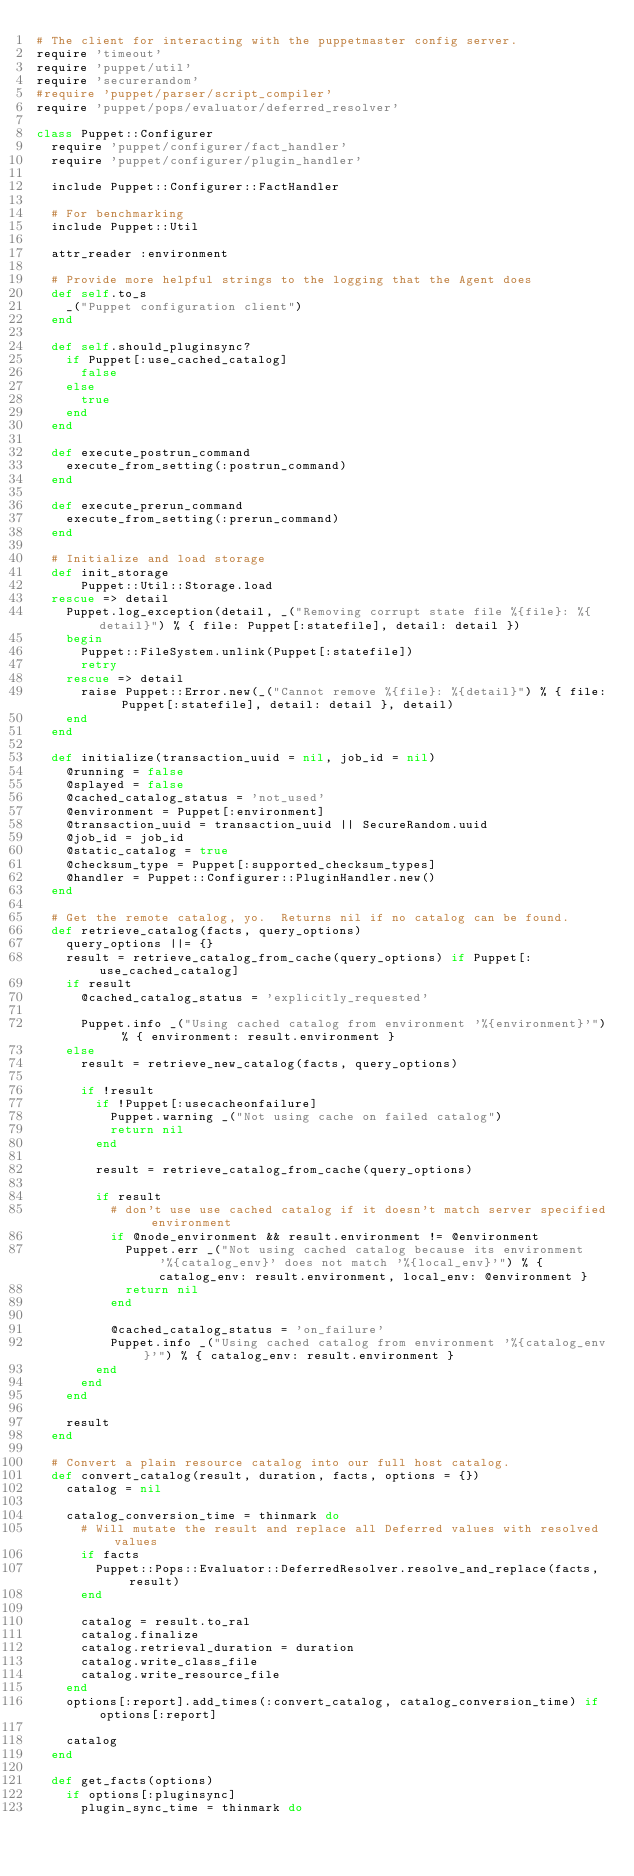Convert code to text. <code><loc_0><loc_0><loc_500><loc_500><_Ruby_># The client for interacting with the puppetmaster config server.
require 'timeout'
require 'puppet/util'
require 'securerandom'
#require 'puppet/parser/script_compiler'
require 'puppet/pops/evaluator/deferred_resolver'

class Puppet::Configurer
  require 'puppet/configurer/fact_handler'
  require 'puppet/configurer/plugin_handler'

  include Puppet::Configurer::FactHandler

  # For benchmarking
  include Puppet::Util

  attr_reader :environment

  # Provide more helpful strings to the logging that the Agent does
  def self.to_s
    _("Puppet configuration client")
  end

  def self.should_pluginsync?
    if Puppet[:use_cached_catalog]
      false
    else
      true
    end
  end

  def execute_postrun_command
    execute_from_setting(:postrun_command)
  end

  def execute_prerun_command
    execute_from_setting(:prerun_command)
  end

  # Initialize and load storage
  def init_storage
      Puppet::Util::Storage.load
  rescue => detail
    Puppet.log_exception(detail, _("Removing corrupt state file %{file}: %{detail}") % { file: Puppet[:statefile], detail: detail })
    begin
      Puppet::FileSystem.unlink(Puppet[:statefile])
      retry
    rescue => detail
      raise Puppet::Error.new(_("Cannot remove %{file}: %{detail}") % { file: Puppet[:statefile], detail: detail }, detail)
    end
  end

  def initialize(transaction_uuid = nil, job_id = nil)
    @running = false
    @splayed = false
    @cached_catalog_status = 'not_used'
    @environment = Puppet[:environment]
    @transaction_uuid = transaction_uuid || SecureRandom.uuid
    @job_id = job_id
    @static_catalog = true
    @checksum_type = Puppet[:supported_checksum_types]
    @handler = Puppet::Configurer::PluginHandler.new()
  end

  # Get the remote catalog, yo.  Returns nil if no catalog can be found.
  def retrieve_catalog(facts, query_options)
    query_options ||= {}
    result = retrieve_catalog_from_cache(query_options) if Puppet[:use_cached_catalog]
    if result
      @cached_catalog_status = 'explicitly_requested'

      Puppet.info _("Using cached catalog from environment '%{environment}'") % { environment: result.environment }
    else
      result = retrieve_new_catalog(facts, query_options)

      if !result
        if !Puppet[:usecacheonfailure]
          Puppet.warning _("Not using cache on failed catalog")
          return nil
        end

        result = retrieve_catalog_from_cache(query_options)

        if result
          # don't use use cached catalog if it doesn't match server specified environment
          if @node_environment && result.environment != @environment
            Puppet.err _("Not using cached catalog because its environment '%{catalog_env}' does not match '%{local_env}'") % { catalog_env: result.environment, local_env: @environment }
            return nil
          end

          @cached_catalog_status = 'on_failure'
          Puppet.info _("Using cached catalog from environment '%{catalog_env}'") % { catalog_env: result.environment }
        end
      end
    end

    result
  end

  # Convert a plain resource catalog into our full host catalog.
  def convert_catalog(result, duration, facts, options = {})
    catalog = nil

    catalog_conversion_time = thinmark do
      # Will mutate the result and replace all Deferred values with resolved values
      if facts
        Puppet::Pops::Evaluator::DeferredResolver.resolve_and_replace(facts, result)
      end

      catalog = result.to_ral
      catalog.finalize
      catalog.retrieval_duration = duration
      catalog.write_class_file
      catalog.write_resource_file
    end
    options[:report].add_times(:convert_catalog, catalog_conversion_time) if options[:report]

    catalog
  end

  def get_facts(options)
    if options[:pluginsync]
      plugin_sync_time = thinmark do</code> 